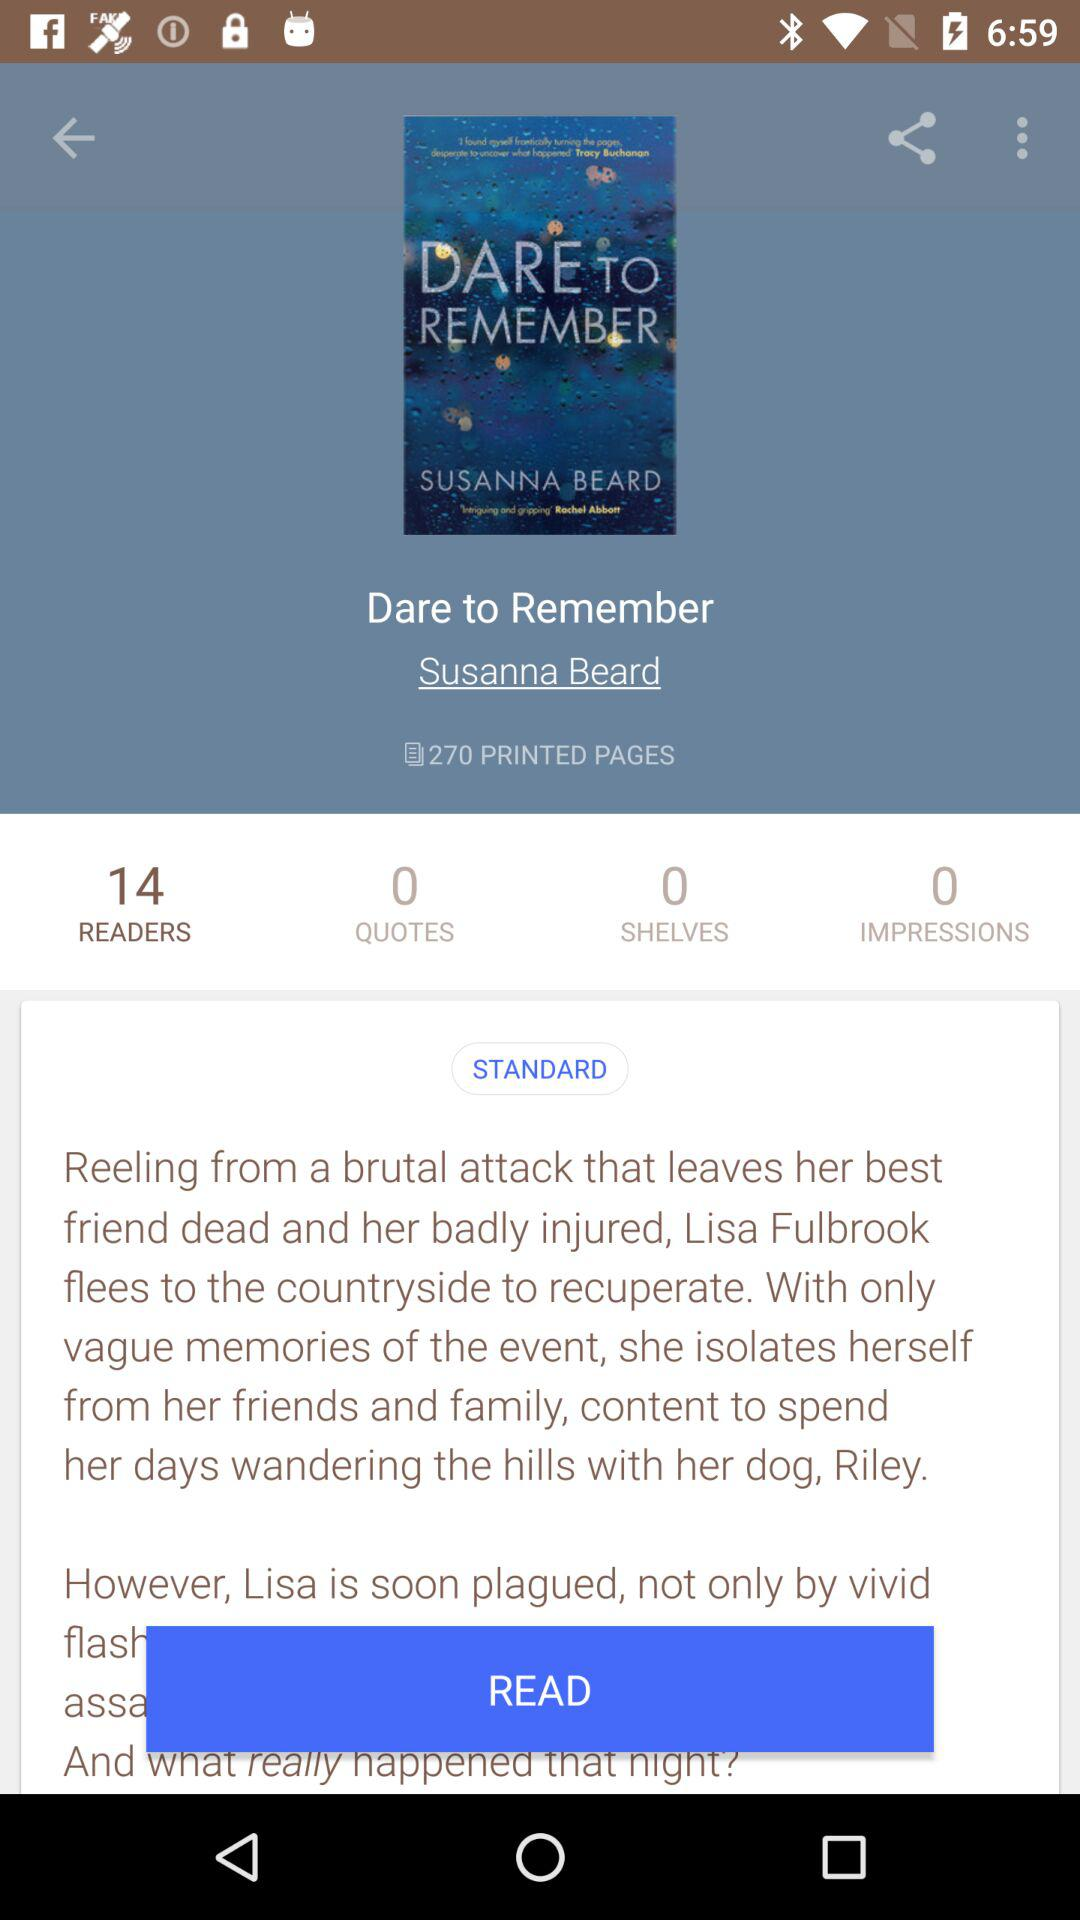On how many shelves is the book available? The book is available on 0 shelves. 